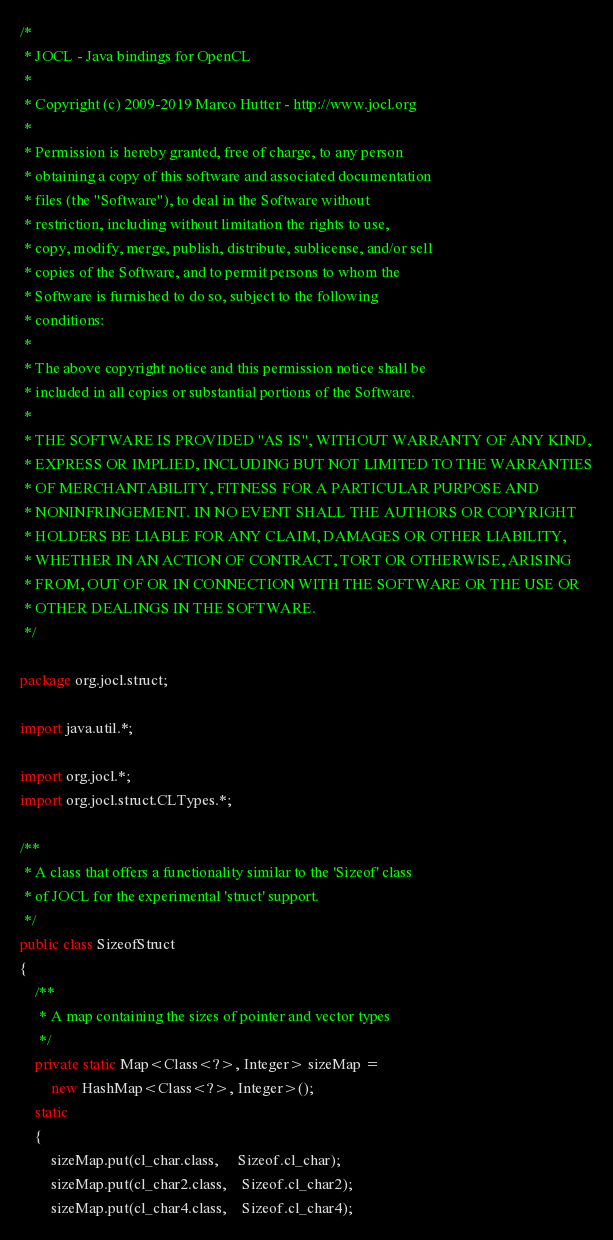<code> <loc_0><loc_0><loc_500><loc_500><_Java_>/*
 * JOCL - Java bindings for OpenCL
 *
 * Copyright (c) 2009-2019 Marco Hutter - http://www.jocl.org
 * 
 * Permission is hereby granted, free of charge, to any person
 * obtaining a copy of this software and associated documentation
 * files (the "Software"), to deal in the Software without
 * restriction, including without limitation the rights to use,
 * copy, modify, merge, publish, distribute, sublicense, and/or sell
 * copies of the Software, and to permit persons to whom the
 * Software is furnished to do so, subject to the following
 * conditions:
 * 
 * The above copyright notice and this permission notice shall be
 * included in all copies or substantial portions of the Software.
 * 
 * THE SOFTWARE IS PROVIDED "AS IS", WITHOUT WARRANTY OF ANY KIND,
 * EXPRESS OR IMPLIED, INCLUDING BUT NOT LIMITED TO THE WARRANTIES
 * OF MERCHANTABILITY, FITNESS FOR A PARTICULAR PURPOSE AND
 * NONINFRINGEMENT. IN NO EVENT SHALL THE AUTHORS OR COPYRIGHT
 * HOLDERS BE LIABLE FOR ANY CLAIM, DAMAGES OR OTHER LIABILITY,
 * WHETHER IN AN ACTION OF CONTRACT, TORT OR OTHERWISE, ARISING
 * FROM, OUT OF OR IN CONNECTION WITH THE SOFTWARE OR THE USE OR
 * OTHER DEALINGS IN THE SOFTWARE.
 */

package org.jocl.struct;

import java.util.*;

import org.jocl.*;
import org.jocl.struct.CLTypes.*;

/**
 * A class that offers a functionality similar to the 'Sizeof' class
 * of JOCL for the experimental 'struct' support.
 */
public class SizeofStruct
{
    /**
     * A map containing the sizes of pointer and vector types
     */
    private static Map<Class<?>, Integer> sizeMap = 
        new HashMap<Class<?>, Integer>();
    static
    {
        sizeMap.put(cl_char.class,     Sizeof.cl_char);
        sizeMap.put(cl_char2.class,    Sizeof.cl_char2);
        sizeMap.put(cl_char4.class,    Sizeof.cl_char4);</code> 